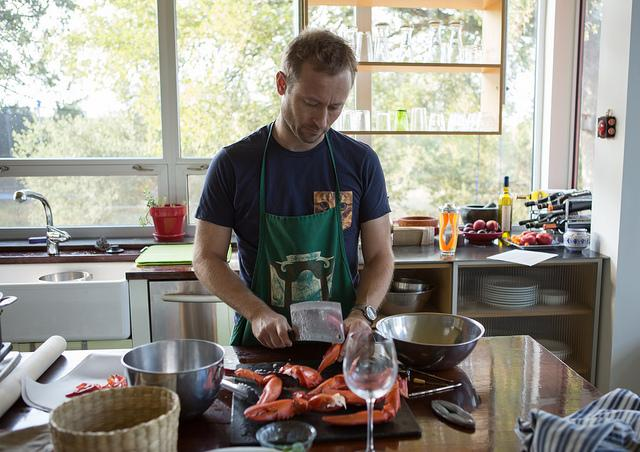What is the man in the apron cooking?

Choices:
A) lobster
B) lamb
C) sausage
D) salmon lobster 